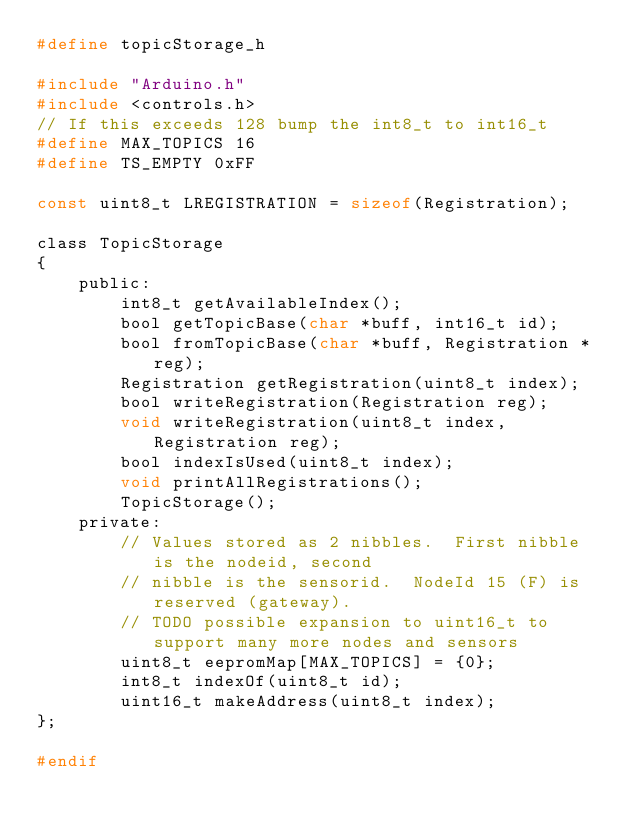Convert code to text. <code><loc_0><loc_0><loc_500><loc_500><_C_>#define topicStorage_h

#include "Arduino.h"
#include <controls.h>
// If this exceeds 128 bump the int8_t to int16_t
#define MAX_TOPICS 16
#define TS_EMPTY 0xFF

const uint8_t LREGISTRATION = sizeof(Registration);

class TopicStorage
{
    public:
        int8_t getAvailableIndex();
        bool getTopicBase(char *buff, int16_t id);
        bool fromTopicBase(char *buff, Registration *reg);
        Registration getRegistration(uint8_t index);
        bool writeRegistration(Registration reg);
        void writeRegistration(uint8_t index, Registration reg);
        bool indexIsUsed(uint8_t index);
        void printAllRegistrations();
        TopicStorage();
    private:
        // Values stored as 2 nibbles.  First nibble is the nodeid, second 
        // nibble is the sensorid.  NodeId 15 (F) is reserved (gateway).  
        // TODO possible expansion to uint16_t to support many more nodes and sensors
        uint8_t eepromMap[MAX_TOPICS] = {0}; 
        int8_t indexOf(uint8_t id);
        uint16_t makeAddress(uint8_t index);
};

#endif
</code> 